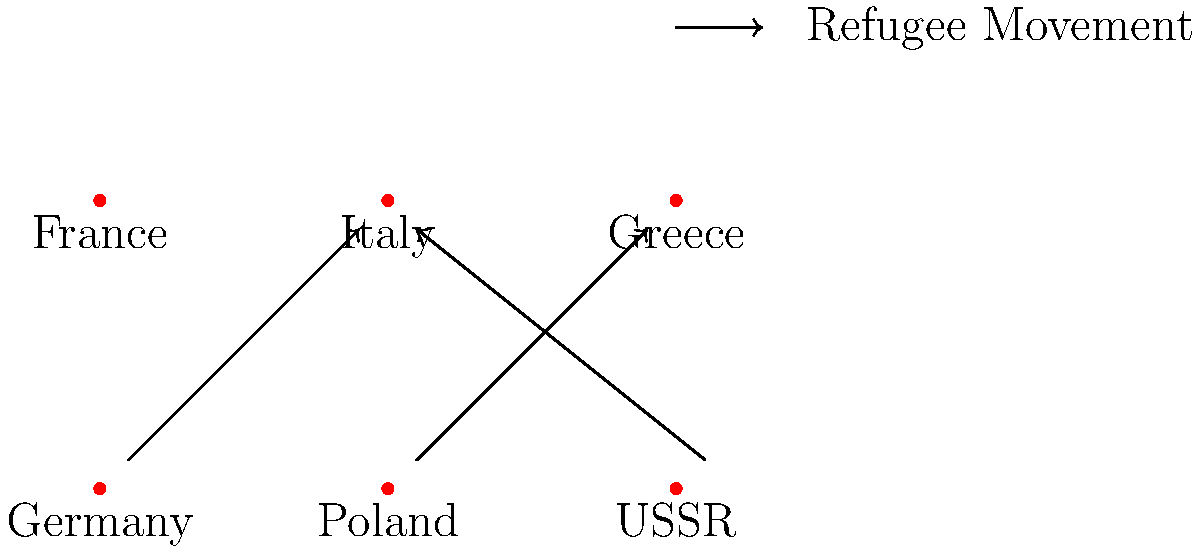Based on the map of refugee movements during World War II, which country appears to have received the highest influx of displaced populations? To answer this question, we need to analyze the arrows on the map representing refugee movements:

1. We see three main refugee movement arrows:
   a) From Germany to Italy
   b) From Poland to Greece
   c) From USSR to Italy

2. Count the number of arrows pointing to each country:
   - Italy: 2 arrows (from Germany and USSR)
   - Greece: 1 arrow (from Poland)
   - Other countries: 0 arrows

3. Italy has the highest number of incoming arrows (2), indicating it received refugees from two different countries.

4. This suggests that Italy likely experienced the highest influx of displaced populations during World War II, based on the information provided in the map.

5. It's important to note that this map is a simplified representation and doesn't show the scale or exact numbers of refugees. However, for the purpose of this question, we can conclude that Italy appears to have received the highest influx of displaced populations.
Answer: Italy 